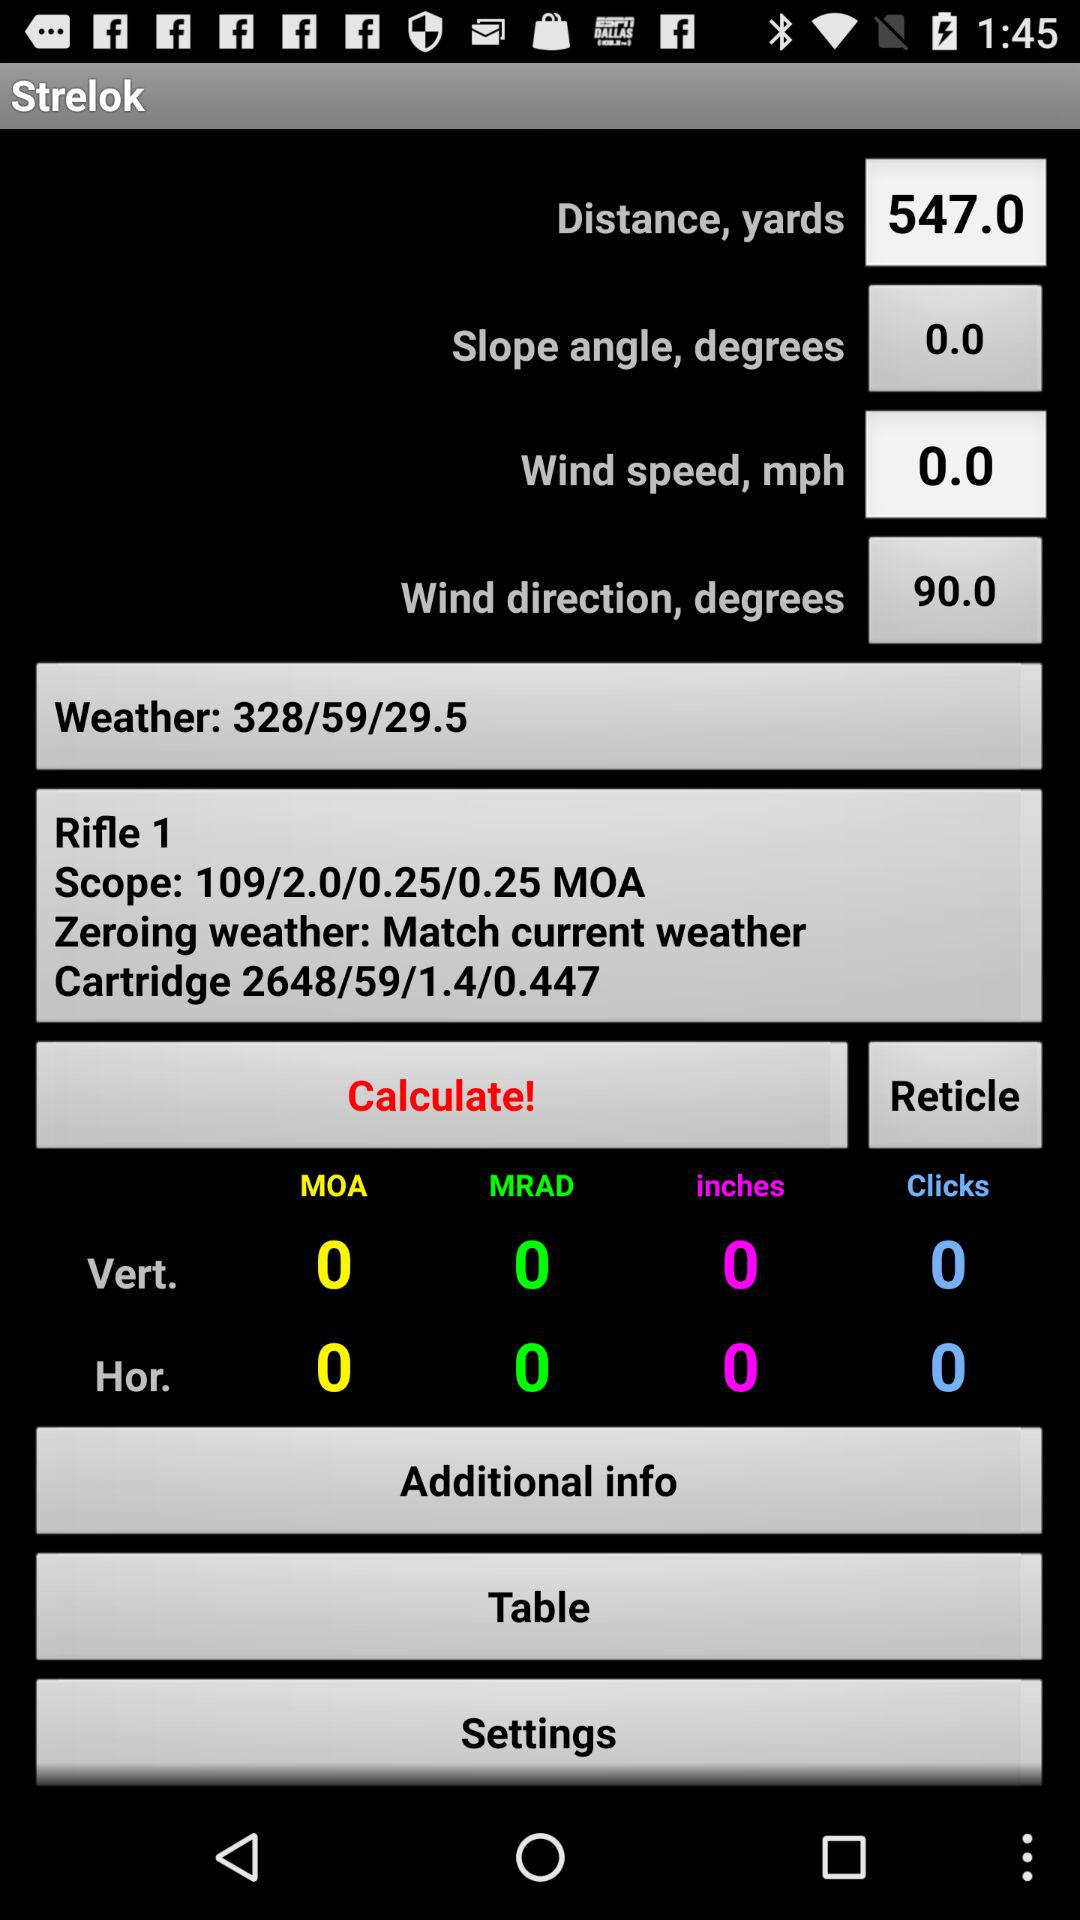What is the current wind direction?
Answer the question using a single word or phrase. 90.0 